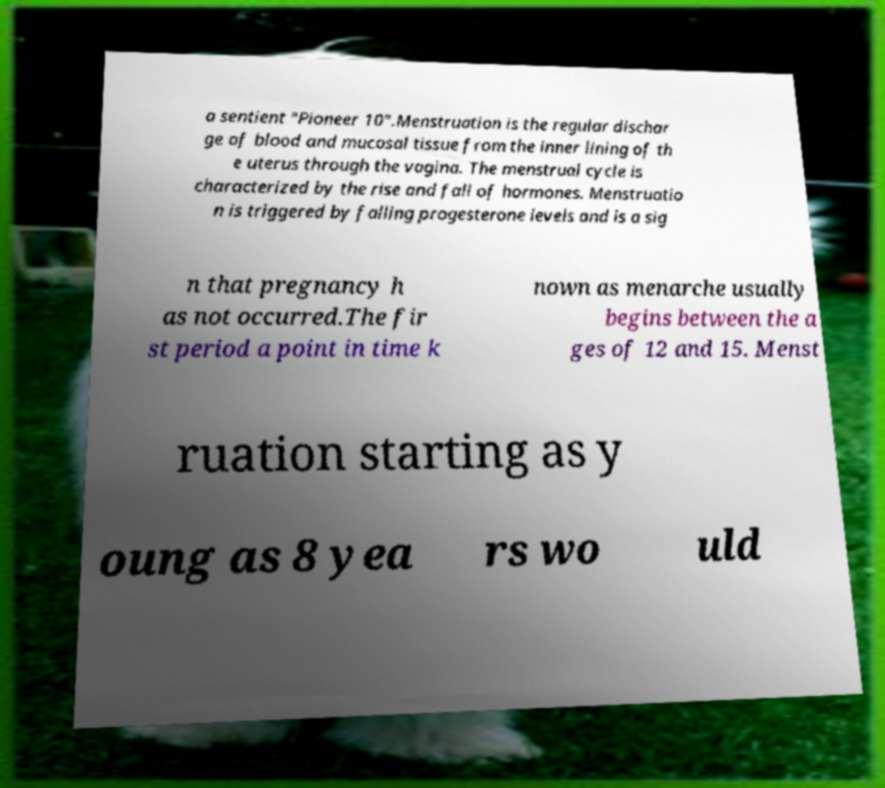Could you assist in decoding the text presented in this image and type it out clearly? a sentient "Pioneer 10".Menstruation is the regular dischar ge of blood and mucosal tissue from the inner lining of th e uterus through the vagina. The menstrual cycle is characterized by the rise and fall of hormones. Menstruatio n is triggered by falling progesterone levels and is a sig n that pregnancy h as not occurred.The fir st period a point in time k nown as menarche usually begins between the a ges of 12 and 15. Menst ruation starting as y oung as 8 yea rs wo uld 